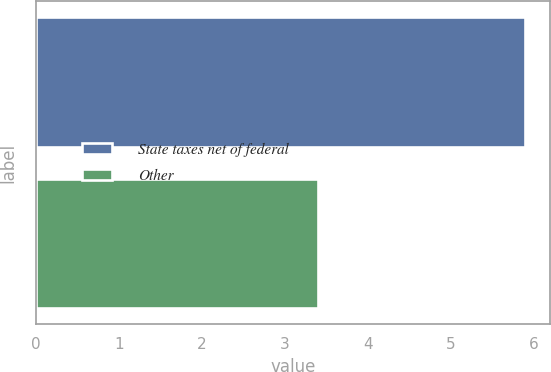<chart> <loc_0><loc_0><loc_500><loc_500><bar_chart><fcel>State taxes net of federal<fcel>Other<nl><fcel>5.9<fcel>3.4<nl></chart> 